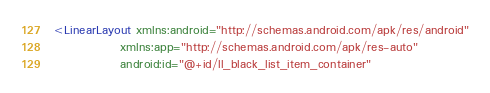<code> <loc_0><loc_0><loc_500><loc_500><_XML_><LinearLayout xmlns:android="http://schemas.android.com/apk/res/android"
              xmlns:app="http://schemas.android.com/apk/res-auto"
              android:id="@+id/ll_black_list_item_container"</code> 